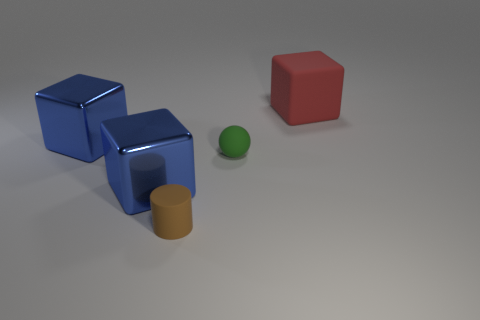Subtract all brown balls. How many blue cubes are left? 2 Subtract all large blue blocks. How many blocks are left? 1 Add 3 green balls. How many objects exist? 8 Subtract all cubes. How many objects are left? 2 Subtract all red blocks. Subtract all blue cylinders. How many blocks are left? 2 Add 3 small objects. How many small objects are left? 5 Add 2 brown rubber cylinders. How many brown rubber cylinders exist? 3 Subtract 0 gray cylinders. How many objects are left? 5 Subtract all big blue shiny objects. Subtract all red blocks. How many objects are left? 2 